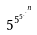Convert formula to latex. <formula><loc_0><loc_0><loc_500><loc_500>5 ^ { 5 ^ { 5 ^ { . ^ { . ^ { n } } } } }</formula> 